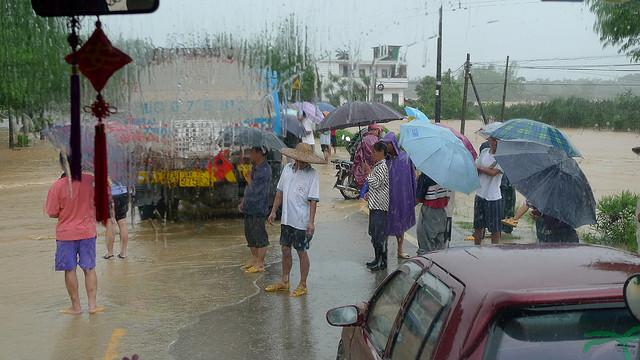What are the people holding the umbrellas trying to avoid?

Choices:
A) rain
B) sun
C) snow
D) wind rain 